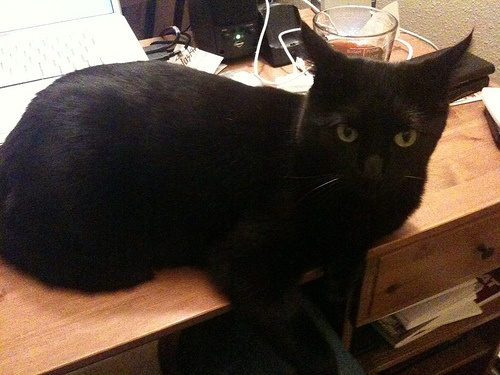Describe the objects in this image and their specific colors. I can see cat in ivory, black, gray, and maroon tones, keyboard in ivory, white, gray, and darkgray tones, cup in ivory, tan, and gray tones, book in ivory, black, gray, maroon, and tan tones, and book in ivory, gray, brown, and tan tones in this image. 